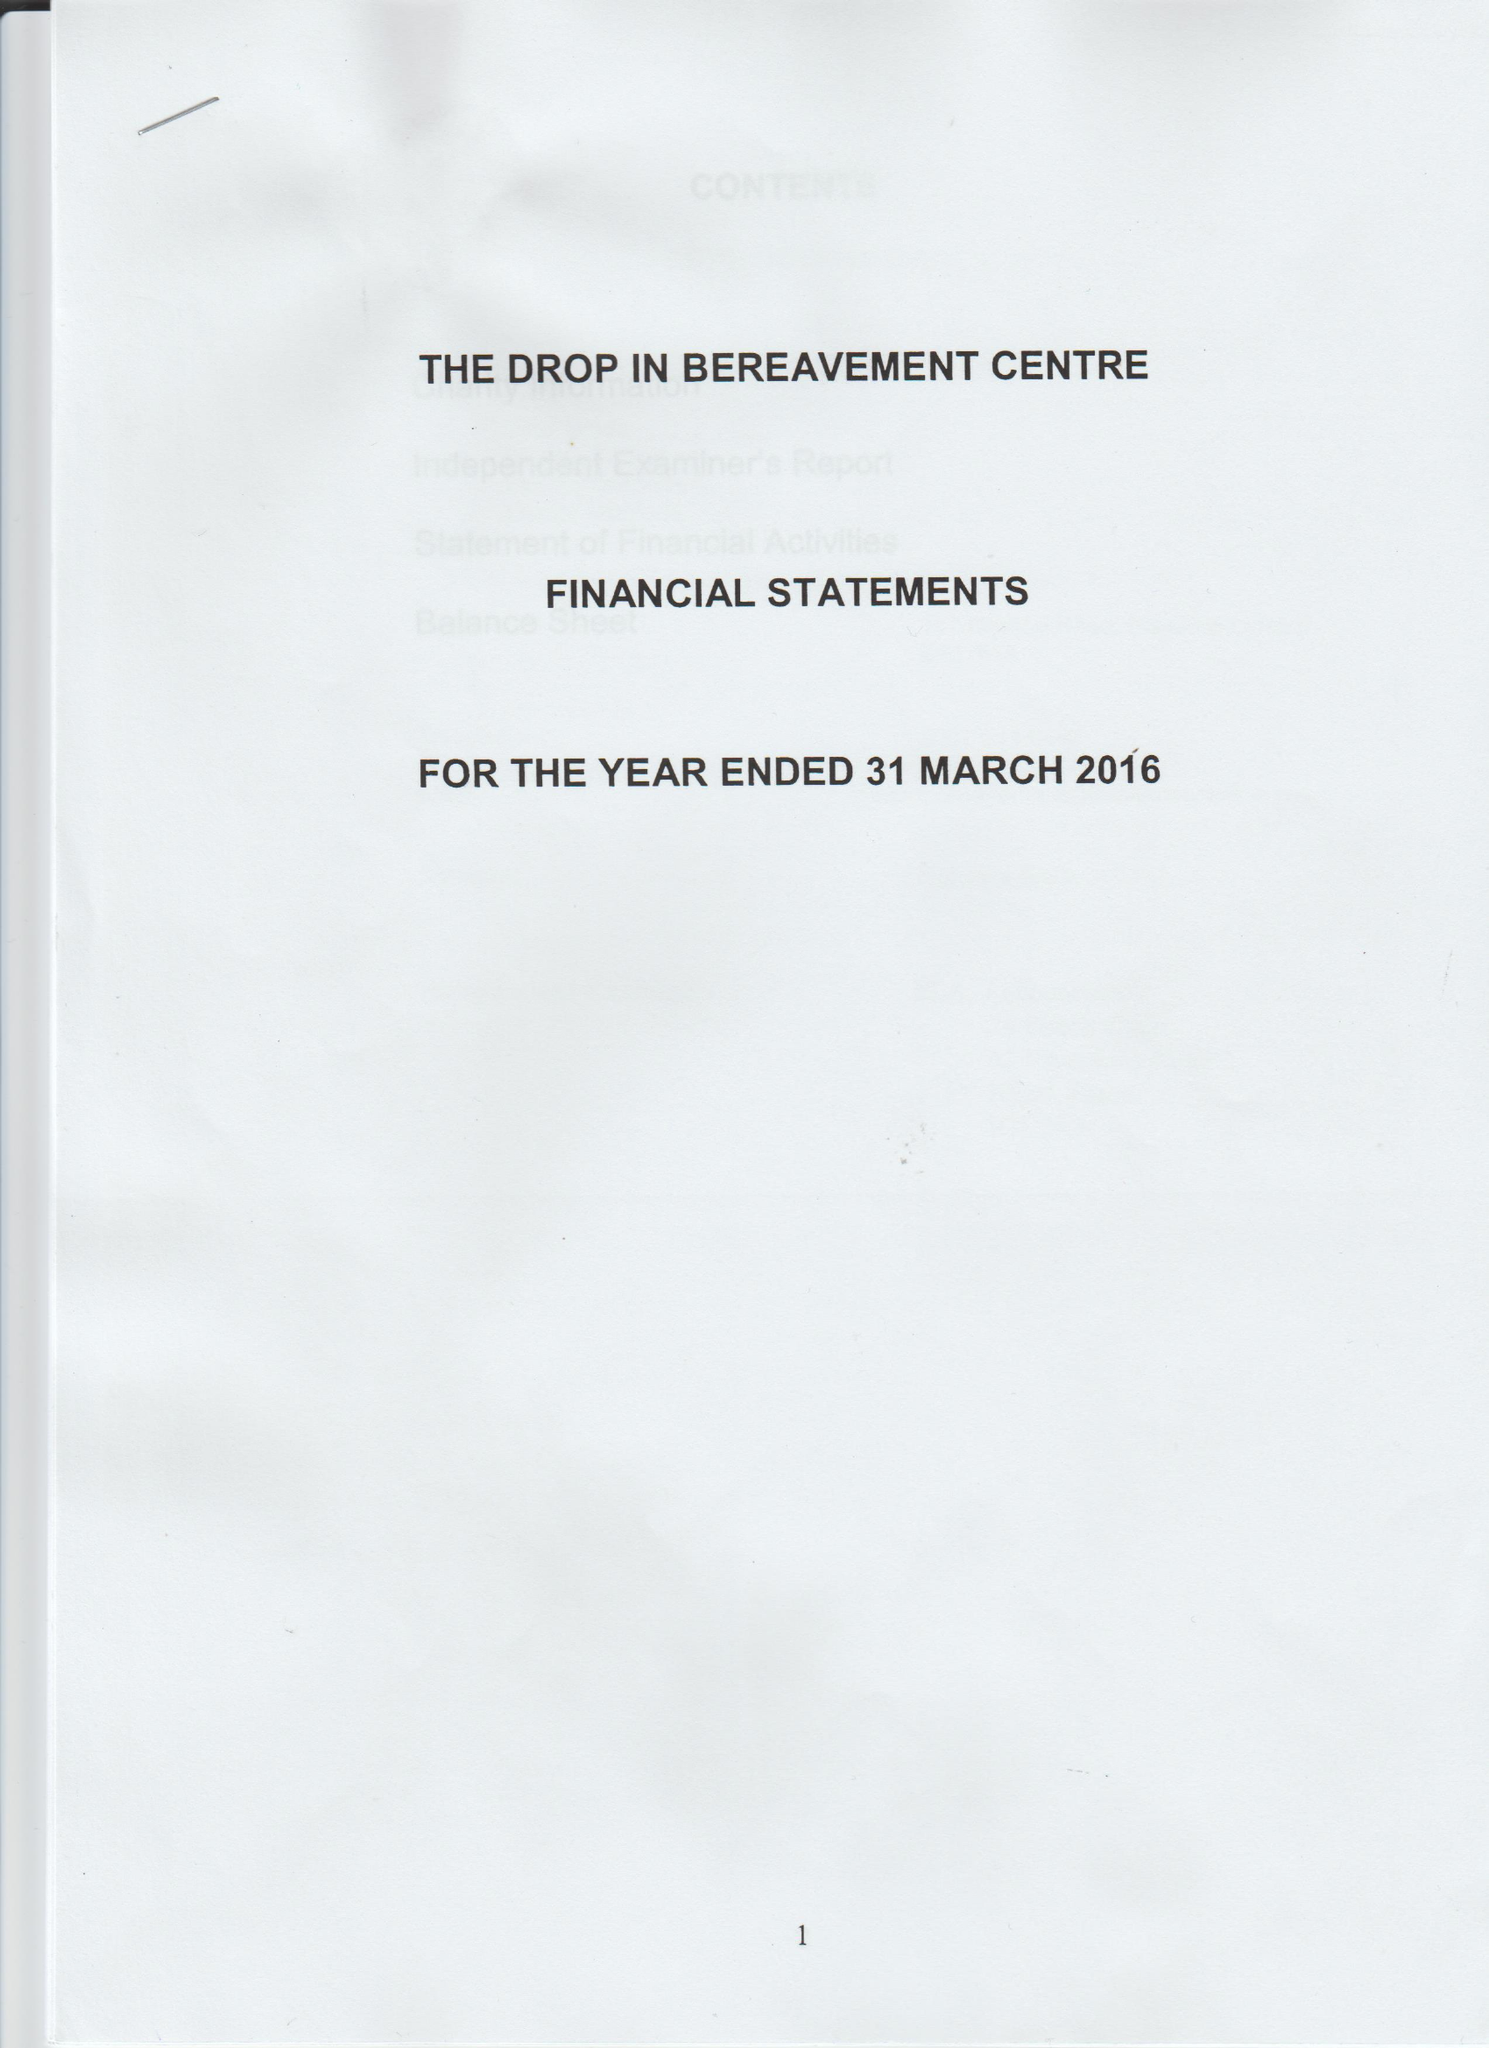What is the value for the address__street_line?
Answer the question using a single word or phrase. 187 GRANGE ROAD 